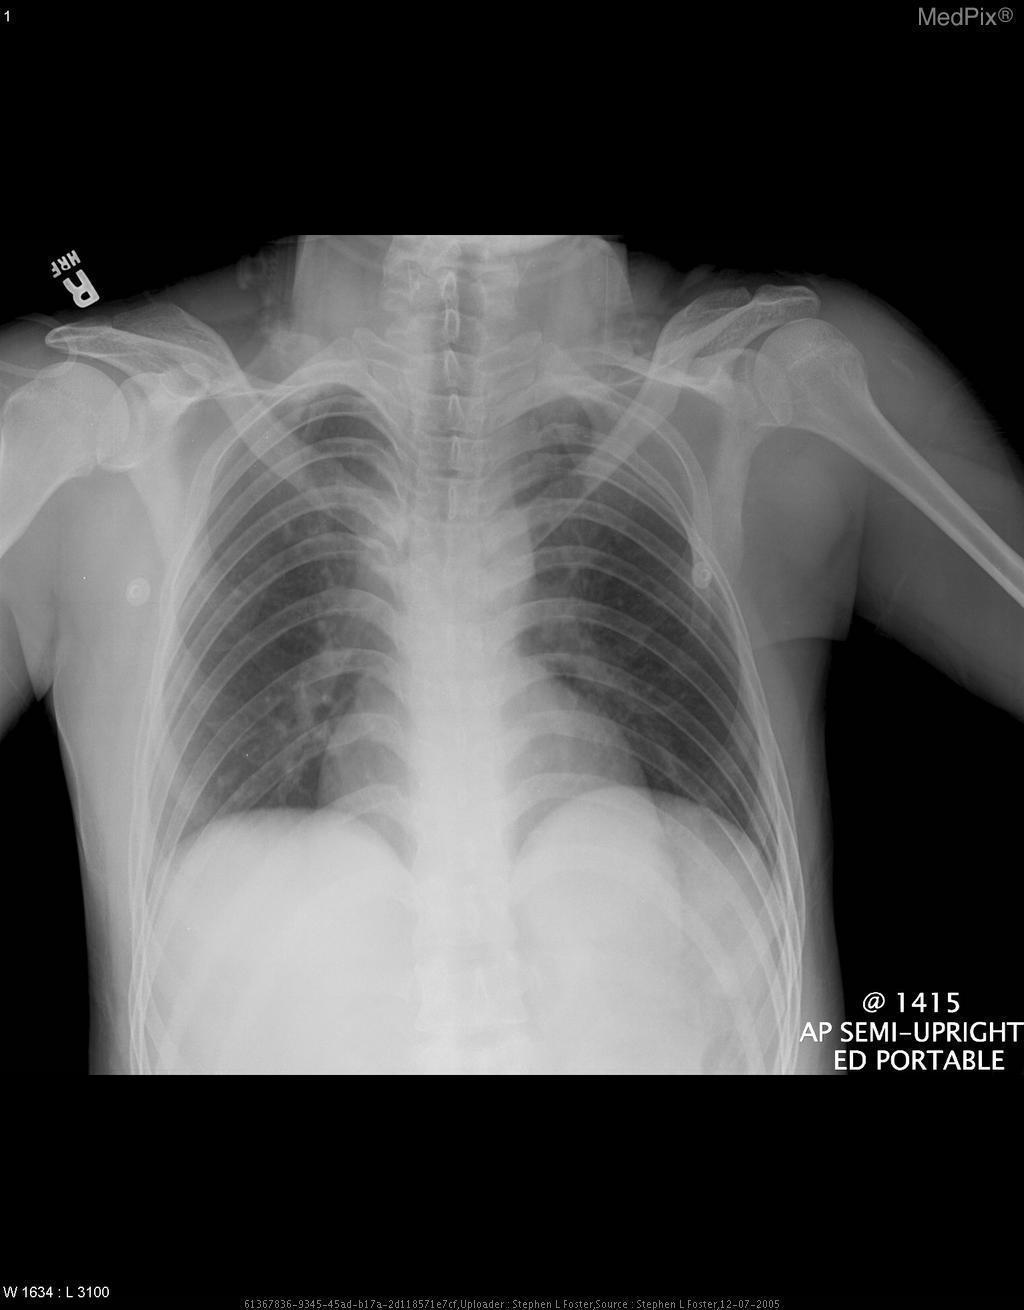Why is the left hemithorax more lucent?
Be succinct. Decreased muscle bulk. What organ system is shown in the above image?
Quick response, please. Cardiopulmonary. The image shows what organ system?
Answer briefly. Cardiopulmonary. In what position was the patient in when this image was taken?
Give a very brief answer. Semi-upright position. What position is the patient in for this image?
Be succinct. Semi-upright position. Are the patients' ribs symmetric on both sides?
Answer briefly. No. Is there symmetry of the patient's ribs on both sides?
Write a very short answer. No. 